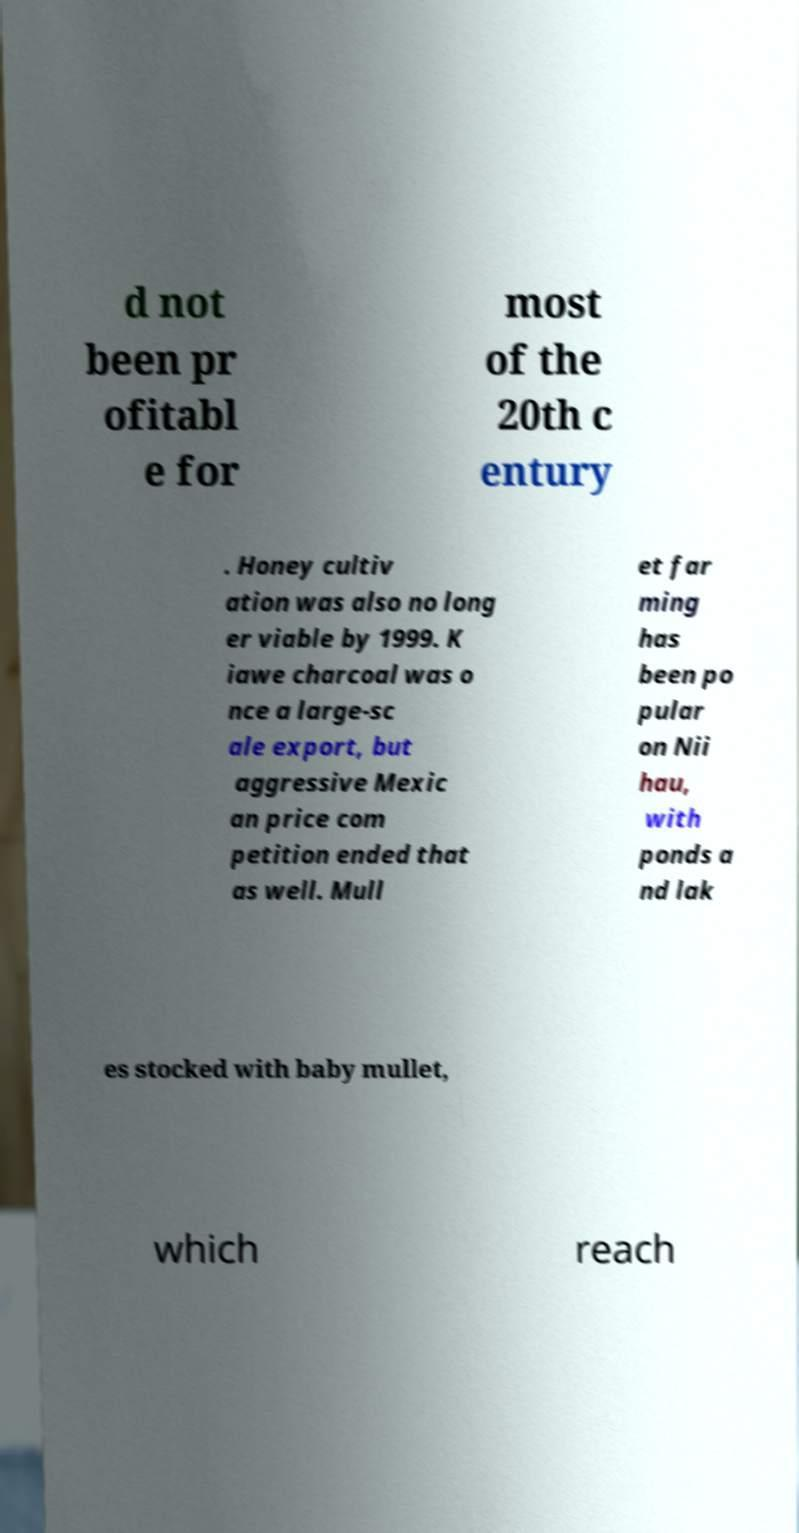For documentation purposes, I need the text within this image transcribed. Could you provide that? d not been pr ofitabl e for most of the 20th c entury . Honey cultiv ation was also no long er viable by 1999. K iawe charcoal was o nce a large-sc ale export, but aggressive Mexic an price com petition ended that as well. Mull et far ming has been po pular on Nii hau, with ponds a nd lak es stocked with baby mullet, which reach 